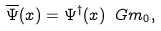<formula> <loc_0><loc_0><loc_500><loc_500>\overline { \Psi } ( x ) = \Psi ^ { \dagger } ( x ) \ G m _ { 0 } ,</formula> 